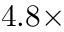<formula> <loc_0><loc_0><loc_500><loc_500>4 . 8 \times</formula> 